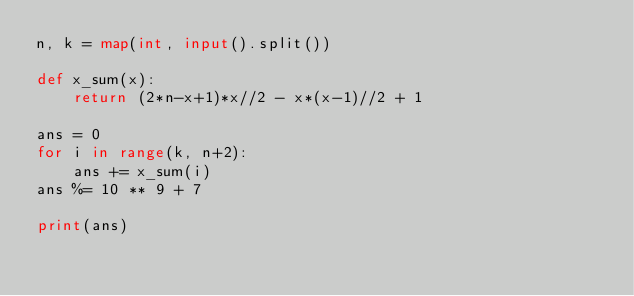<code> <loc_0><loc_0><loc_500><loc_500><_Python_>n, k = map(int, input().split())

def x_sum(x):
    return (2*n-x+1)*x//2 - x*(x-1)//2 + 1

ans = 0 
for i in range(k, n+2):
    ans += x_sum(i)
ans %= 10 ** 9 + 7

print(ans)
</code> 